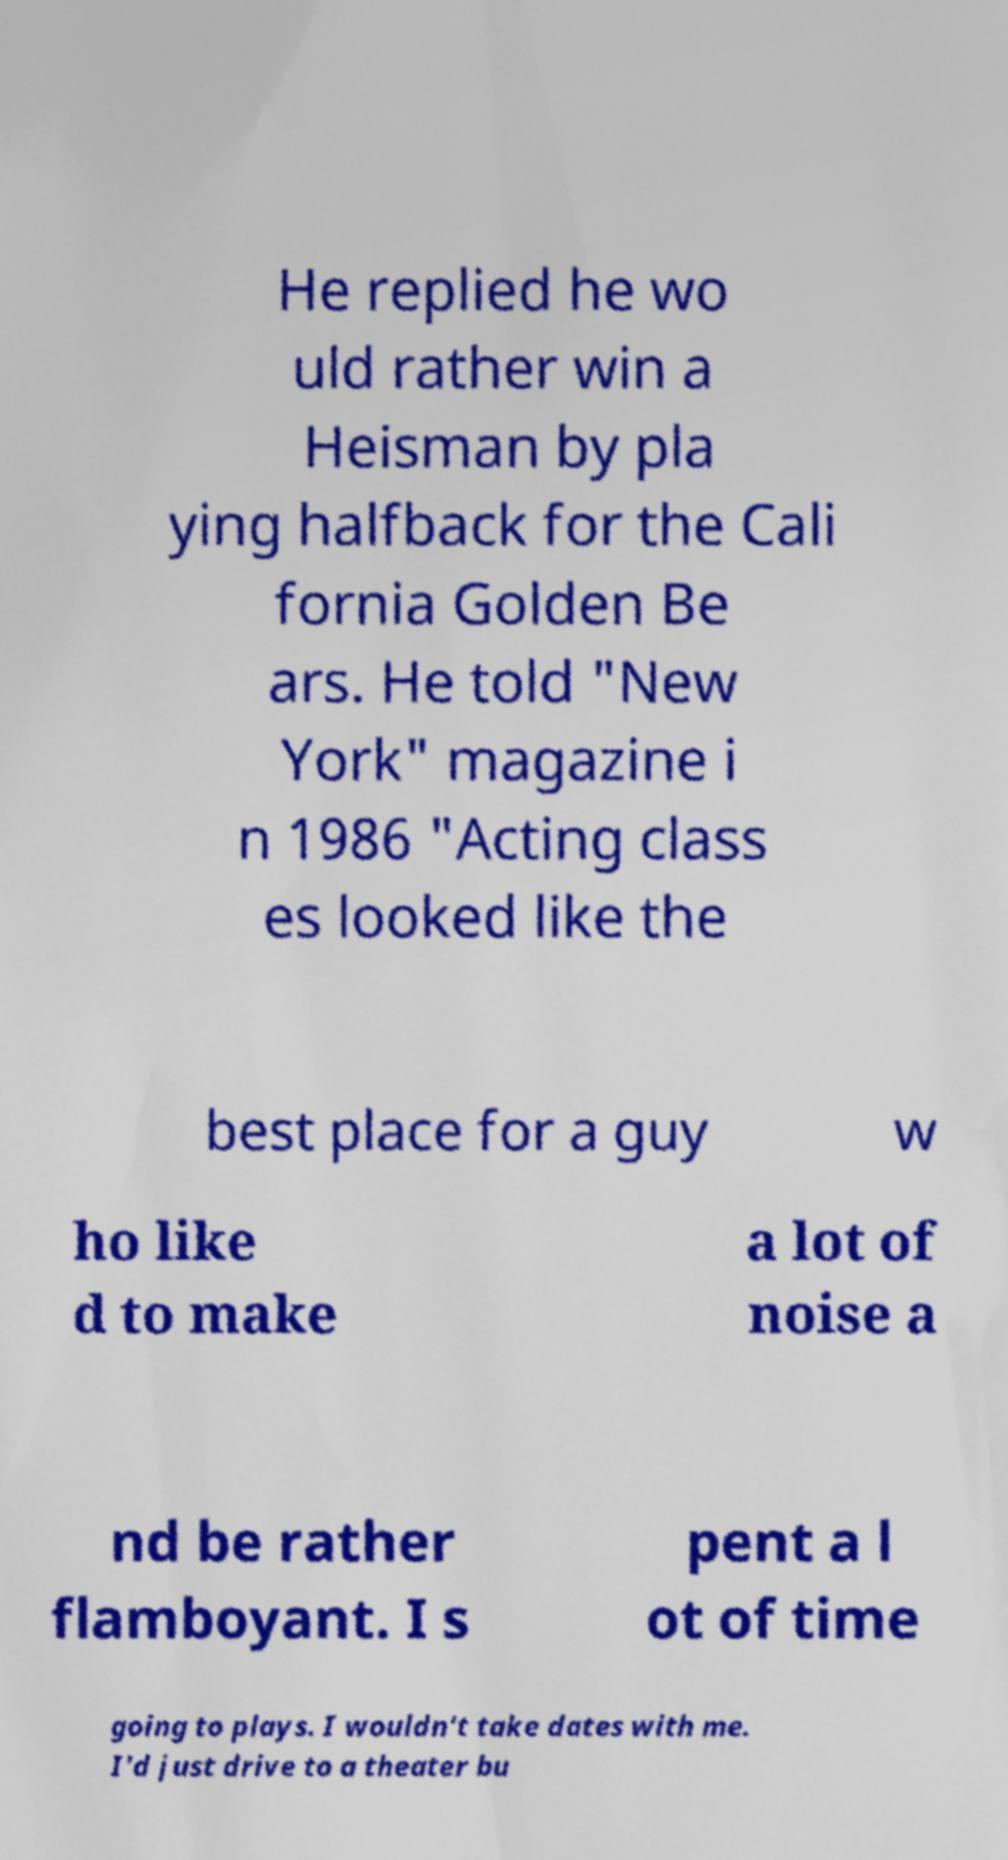Could you extract and type out the text from this image? He replied he wo uld rather win a Heisman by pla ying halfback for the Cali fornia Golden Be ars. He told "New York" magazine i n 1986 "Acting class es looked like the best place for a guy w ho like d to make a lot of noise a nd be rather flamboyant. I s pent a l ot of time going to plays. I wouldn't take dates with me. I'd just drive to a theater bu 